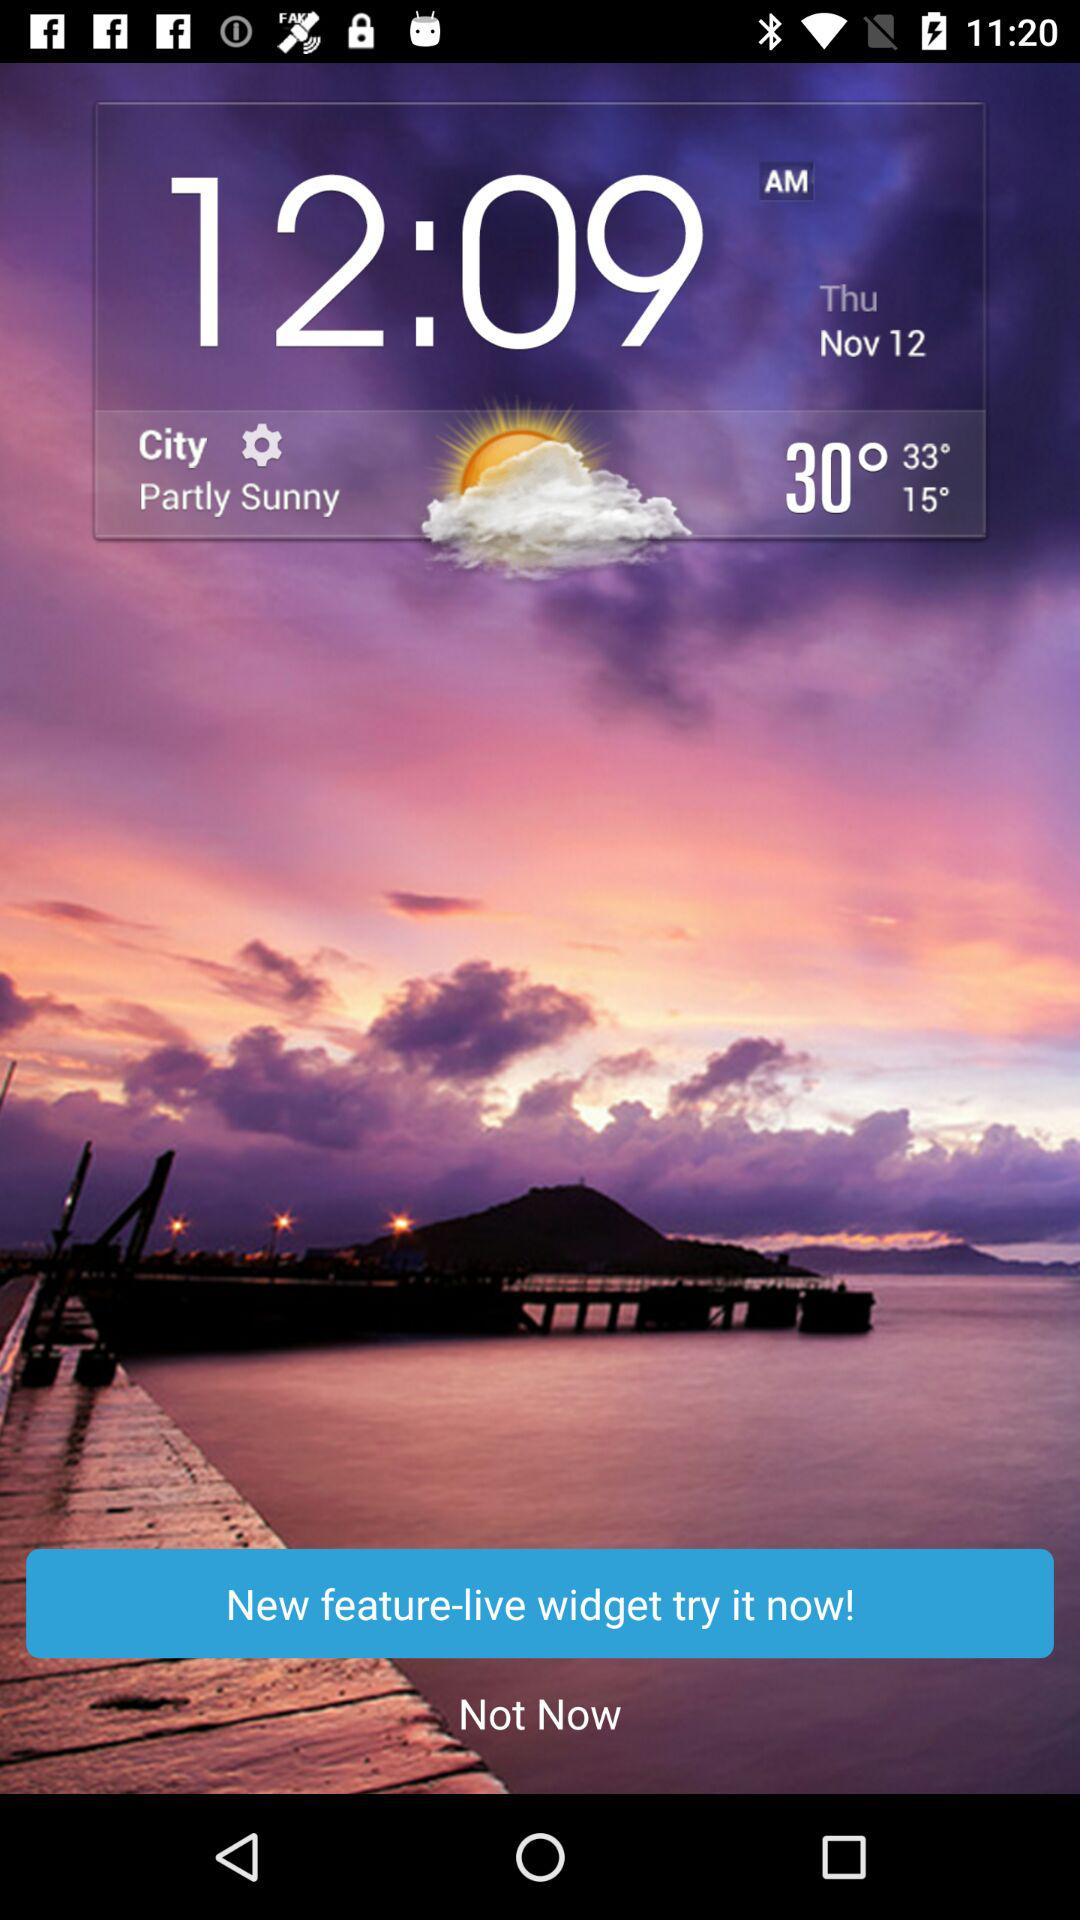What is the time? The time is 12:09 a.m. 